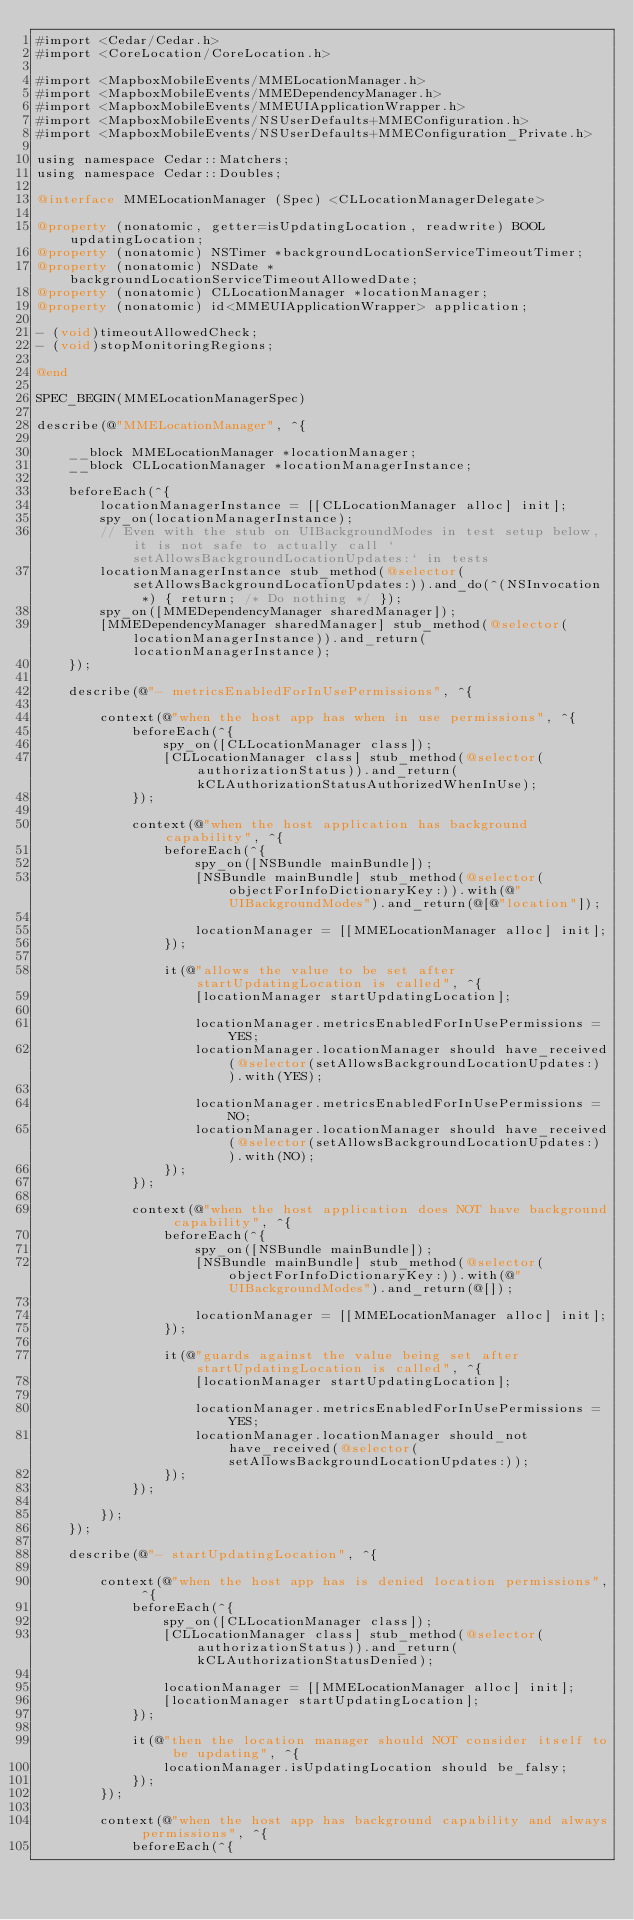<code> <loc_0><loc_0><loc_500><loc_500><_ObjectiveC_>#import <Cedar/Cedar.h>
#import <CoreLocation/CoreLocation.h>

#import <MapboxMobileEvents/MMELocationManager.h>
#import <MapboxMobileEvents/MMEDependencyManager.h>
#import <MapboxMobileEvents/MMEUIApplicationWrapper.h>
#import <MapboxMobileEvents/NSUserDefaults+MMEConfiguration.h>
#import <MapboxMobileEvents/NSUserDefaults+MMEConfiguration_Private.h>

using namespace Cedar::Matchers;
using namespace Cedar::Doubles;

@interface MMELocationManager (Spec) <CLLocationManagerDelegate>

@property (nonatomic, getter=isUpdatingLocation, readwrite) BOOL updatingLocation;
@property (nonatomic) NSTimer *backgroundLocationServiceTimeoutTimer;
@property (nonatomic) NSDate *backgroundLocationServiceTimeoutAllowedDate;
@property (nonatomic) CLLocationManager *locationManager;
@property (nonatomic) id<MMEUIApplicationWrapper> application;

- (void)timeoutAllowedCheck;
- (void)stopMonitoringRegions;

@end

SPEC_BEGIN(MMELocationManagerSpec)

describe(@"MMELocationManager", ^{
    
    __block MMELocationManager *locationManager;
    __block CLLocationManager *locationManagerInstance;
    
    beforeEach(^{
        locationManagerInstance = [[CLLocationManager alloc] init];
        spy_on(locationManagerInstance);
        // Even with the stub on UIBackgroundModes in test setup below, it is not safe to actually call `setAllowsBackgroundLocationUpdates:` in tests
        locationManagerInstance stub_method(@selector(setAllowsBackgroundLocationUpdates:)).and_do(^(NSInvocation *) { return; /* Do nothing */ });
        spy_on([MMEDependencyManager sharedManager]);
        [MMEDependencyManager sharedManager] stub_method(@selector(locationManagerInstance)).and_return(locationManagerInstance);
    });
    
    describe(@"- metricsEnabledForInUsePermissions", ^{
        
        context(@"when the host app has when in use permissions", ^{
            beforeEach(^{
                spy_on([CLLocationManager class]);
                [CLLocationManager class] stub_method(@selector(authorizationStatus)).and_return(kCLAuthorizationStatusAuthorizedWhenInUse);
            });
            
            context(@"when the host application has background capability", ^{
                beforeEach(^{
                    spy_on([NSBundle mainBundle]);
                    [NSBundle mainBundle] stub_method(@selector(objectForInfoDictionaryKey:)).with(@"UIBackgroundModes").and_return(@[@"location"]);
                    
                    locationManager = [[MMELocationManager alloc] init];
                });
                
                it(@"allows the value to be set after startUpdatingLocation is called", ^{
                    [locationManager startUpdatingLocation];
                    
                    locationManager.metricsEnabledForInUsePermissions = YES;
                    locationManager.locationManager should have_received(@selector(setAllowsBackgroundLocationUpdates:)).with(YES);
                    
                    locationManager.metricsEnabledForInUsePermissions = NO;
                    locationManager.locationManager should have_received(@selector(setAllowsBackgroundLocationUpdates:)).with(NO);
                });
            });
            
            context(@"when the host application does NOT have background capability", ^{
                beforeEach(^{
                    spy_on([NSBundle mainBundle]);
                    [NSBundle mainBundle] stub_method(@selector(objectForInfoDictionaryKey:)).with(@"UIBackgroundModes").and_return(@[]);
                    
                    locationManager = [[MMELocationManager alloc] init];
                });
                
                it(@"guards against the value being set after startUpdatingLocation is called", ^{
                    [locationManager startUpdatingLocation];
                    
                    locationManager.metricsEnabledForInUsePermissions = YES;
                    locationManager.locationManager should_not have_received(@selector(setAllowsBackgroundLocationUpdates:));
                });
            });
            
        });
    });
    
    describe(@"- startUpdatingLocation", ^{
        
        context(@"when the host app has is denied location permissions", ^{
            beforeEach(^{
                spy_on([CLLocationManager class]);
                [CLLocationManager class] stub_method(@selector(authorizationStatus)).and_return(kCLAuthorizationStatusDenied);
                
                locationManager = [[MMELocationManager alloc] init];
                [locationManager startUpdatingLocation];
            });
            
            it(@"then the location manager should NOT consider itself to be updating", ^{
                locationManager.isUpdatingLocation should be_falsy;
            });
        });
        
        context(@"when the host app has background capability and always permissions", ^{
            beforeEach(^{</code> 